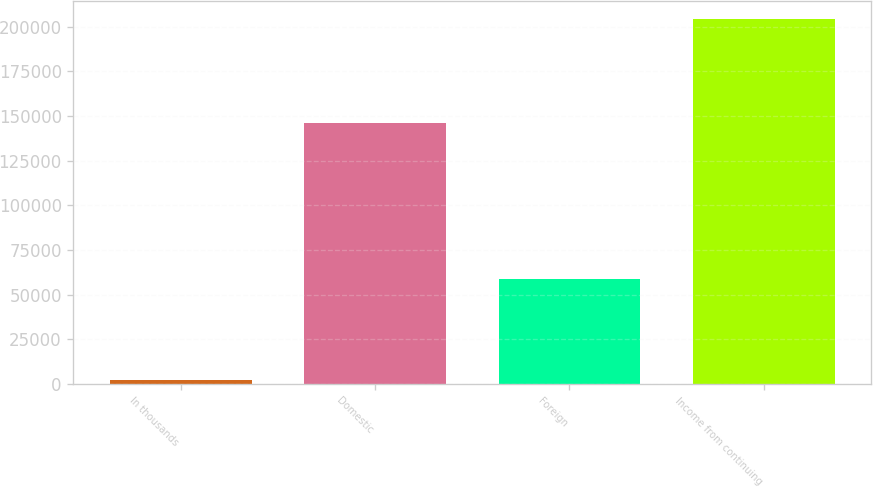Convert chart to OTSL. <chart><loc_0><loc_0><loc_500><loc_500><bar_chart><fcel>In thousands<fcel>Domestic<fcel>Foreign<fcel>Income from continuing<nl><fcel>2008<fcel>145791<fcel>58509<fcel>204300<nl></chart> 